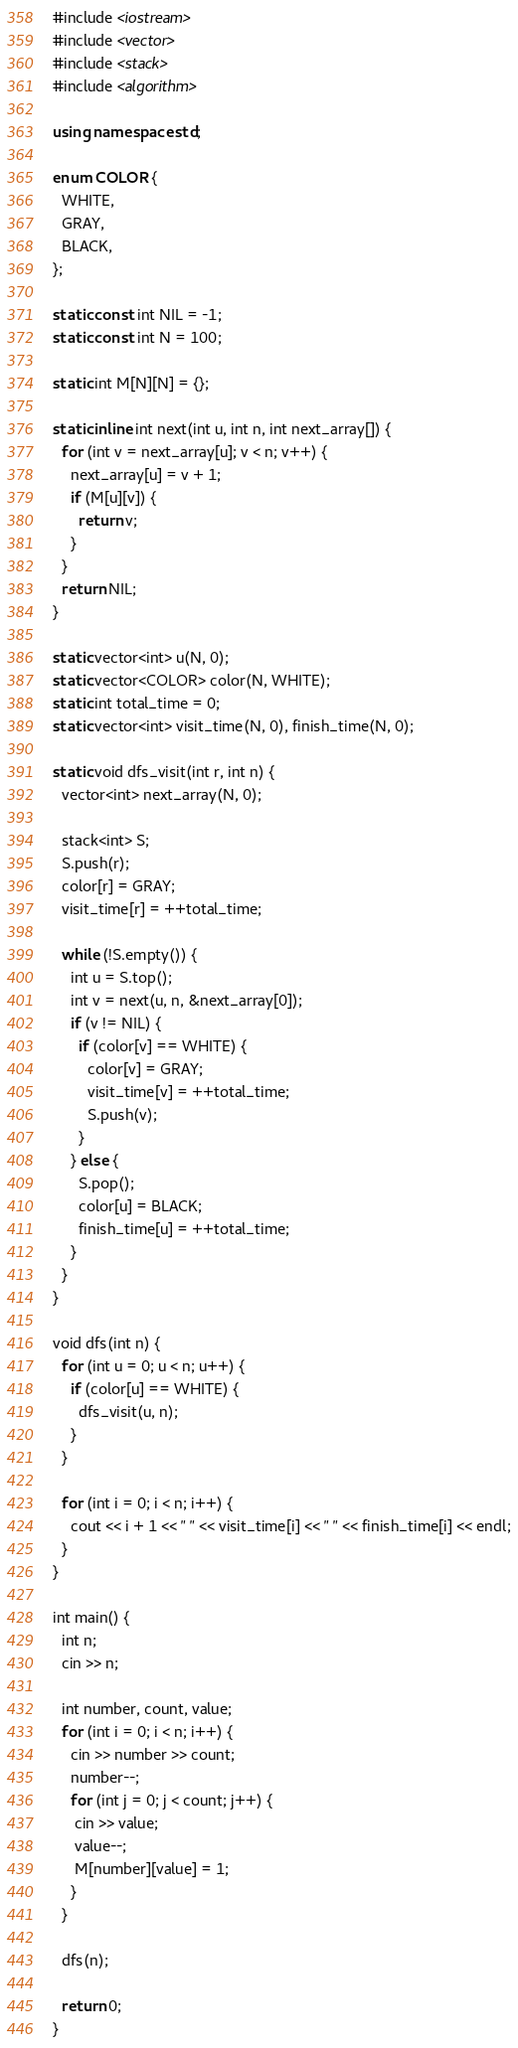<code> <loc_0><loc_0><loc_500><loc_500><_C++_>#include <iostream>
#include <vector>
#include <stack>
#include <algorithm>

using namespace std;

enum COLOR {
  WHITE,
  GRAY,
  BLACK,
};

static const int NIL = -1;
static const int N = 100;

static int M[N][N] = {};

static inline int next(int u, int n, int next_array[]) {
  for (int v = next_array[u]; v < n; v++) {
    next_array[u] = v + 1;
    if (M[u][v]) {
      return v;
    }
  }
  return NIL;
}

static vector<int> u(N, 0);
static vector<COLOR> color(N, WHITE);
static int total_time = 0;
static vector<int> visit_time(N, 0), finish_time(N, 0);

static void dfs_visit(int r, int n) {
  vector<int> next_array(N, 0);

  stack<int> S;
  S.push(r);
  color[r] = GRAY;
  visit_time[r] = ++total_time;

  while (!S.empty()) {
    int u = S.top();
    int v = next(u, n, &next_array[0]);
    if (v != NIL) {
      if (color[v] == WHITE) {
        color[v] = GRAY;
        visit_time[v] = ++total_time;
        S.push(v);
      }
    } else {
      S.pop();
      color[u] = BLACK;
      finish_time[u] = ++total_time;
    }
  }
}

void dfs(int n) {
  for (int u = 0; u < n; u++) {
    if (color[u] == WHITE) {
      dfs_visit(u, n);
    }
  }
  
  for (int i = 0; i < n; i++) {
    cout << i + 1 << " " << visit_time[i] << " " << finish_time[i] << endl;
  }
}

int main() {
  int n;
  cin >> n;

  int number, count, value;
  for (int i = 0; i < n; i++) {
    cin >> number >> count;
    number--;
    for (int j = 0; j < count; j++) {
     cin >> value;
     value--;
     M[number][value] = 1; 
    }
  }
  
  dfs(n);

  return 0;
}

</code> 